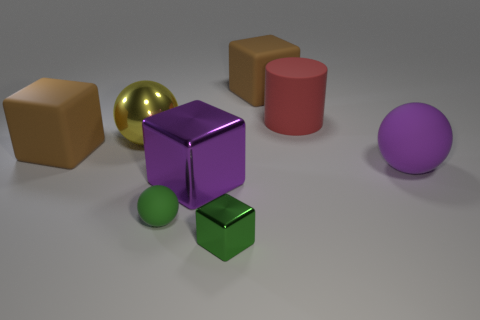How many other objects are the same size as the red matte cylinder? There are five objects that appear to be similar in size to the red matte cylinder, including the gold sphere, the purple cube, the brown cube, the green sphere, and the violet sphere. 